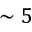<formula> <loc_0><loc_0><loc_500><loc_500>\sim 5</formula> 